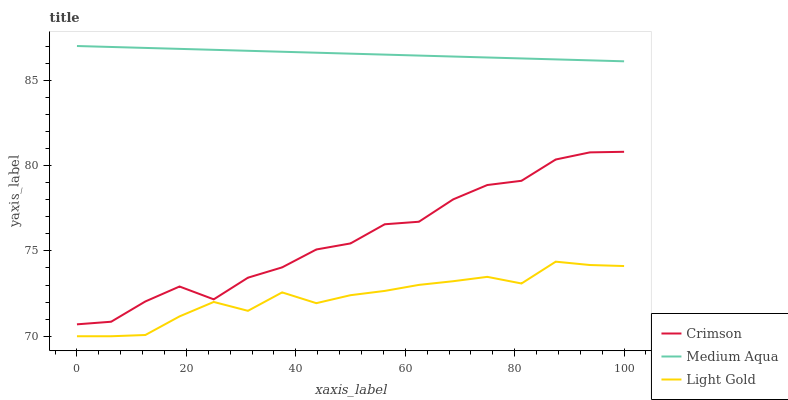Does Light Gold have the minimum area under the curve?
Answer yes or no. Yes. Does Medium Aqua have the maximum area under the curve?
Answer yes or no. Yes. Does Medium Aqua have the minimum area under the curve?
Answer yes or no. No. Does Light Gold have the maximum area under the curve?
Answer yes or no. No. Is Medium Aqua the smoothest?
Answer yes or no. Yes. Is Crimson the roughest?
Answer yes or no. Yes. Is Light Gold the smoothest?
Answer yes or no. No. Is Light Gold the roughest?
Answer yes or no. No. Does Light Gold have the lowest value?
Answer yes or no. Yes. Does Medium Aqua have the lowest value?
Answer yes or no. No. Does Medium Aqua have the highest value?
Answer yes or no. Yes. Does Light Gold have the highest value?
Answer yes or no. No. Is Light Gold less than Medium Aqua?
Answer yes or no. Yes. Is Medium Aqua greater than Crimson?
Answer yes or no. Yes. Does Light Gold intersect Medium Aqua?
Answer yes or no. No. 